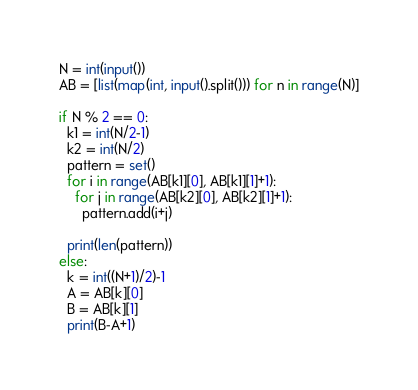<code> <loc_0><loc_0><loc_500><loc_500><_Python_>N = int(input())
AB = [list(map(int, input().split())) for n in range(N)]

if N % 2 == 0:
  k1 = int(N/2-1)
  k2 = int(N/2)
  pattern = set()
  for i in range(AB[k1][0], AB[k1][1]+1):
    for j in range(AB[k2][0], AB[k2][1]+1):
      pattern.add(i+j)
  
  print(len(pattern))
else:
  k = int((N+1)/2)-1
  A = AB[k][0]
  B = AB[k][1]
  print(B-A+1)</code> 